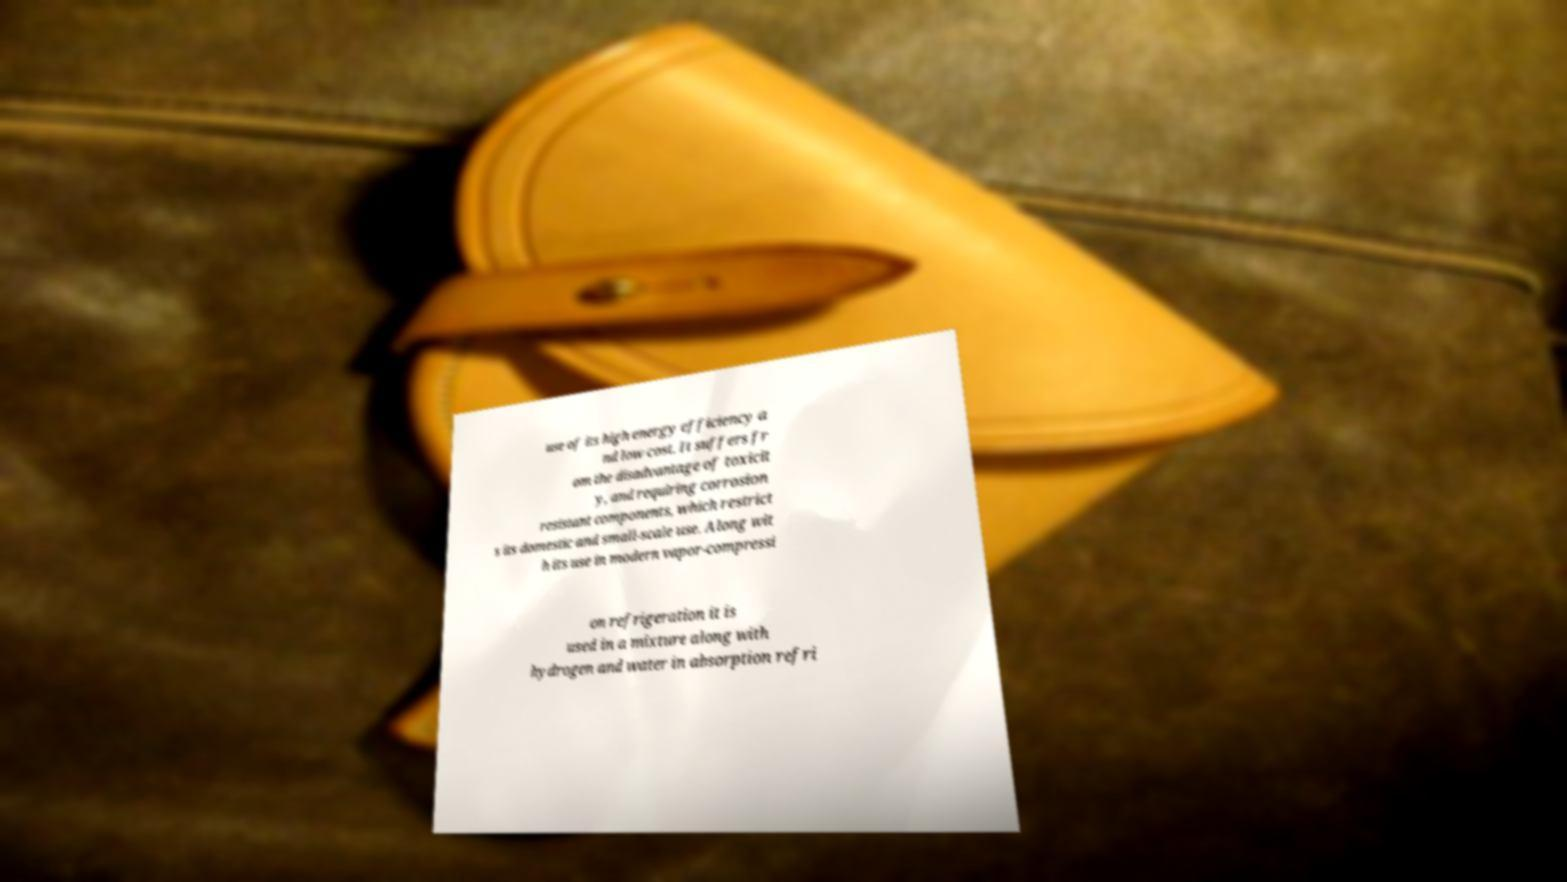I need the written content from this picture converted into text. Can you do that? use of its high energy efficiency a nd low cost. It suffers fr om the disadvantage of toxicit y, and requiring corrosion resistant components, which restrict s its domestic and small-scale use. Along wit h its use in modern vapor-compressi on refrigeration it is used in a mixture along with hydrogen and water in absorption refri 